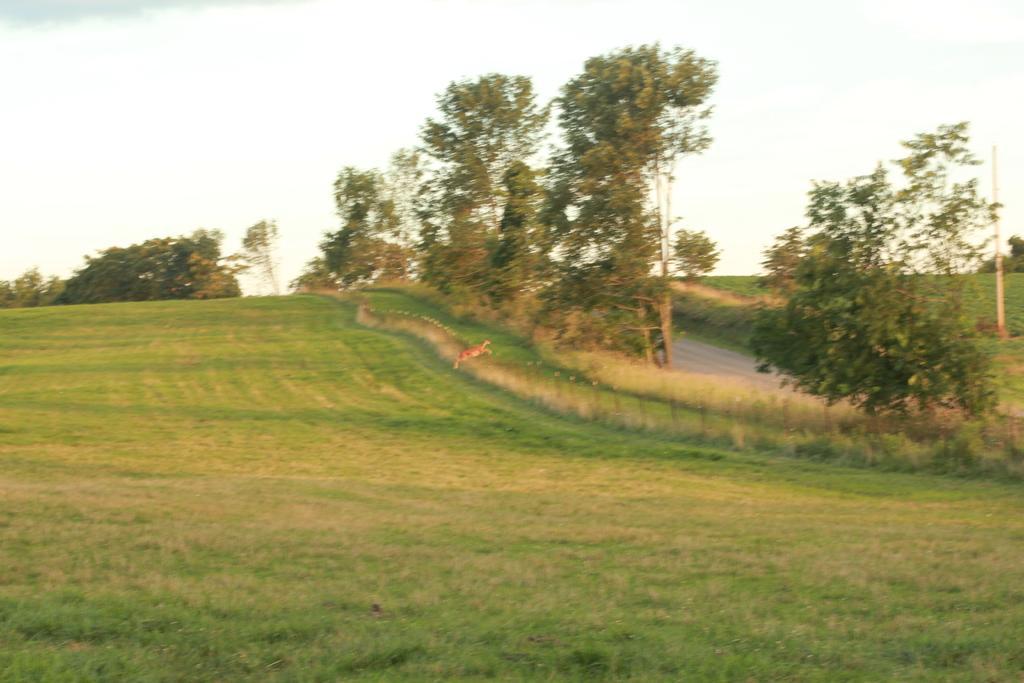Please provide a concise description of this image. As we can see in the image there is grass, fence, an animal, trees and sky. 